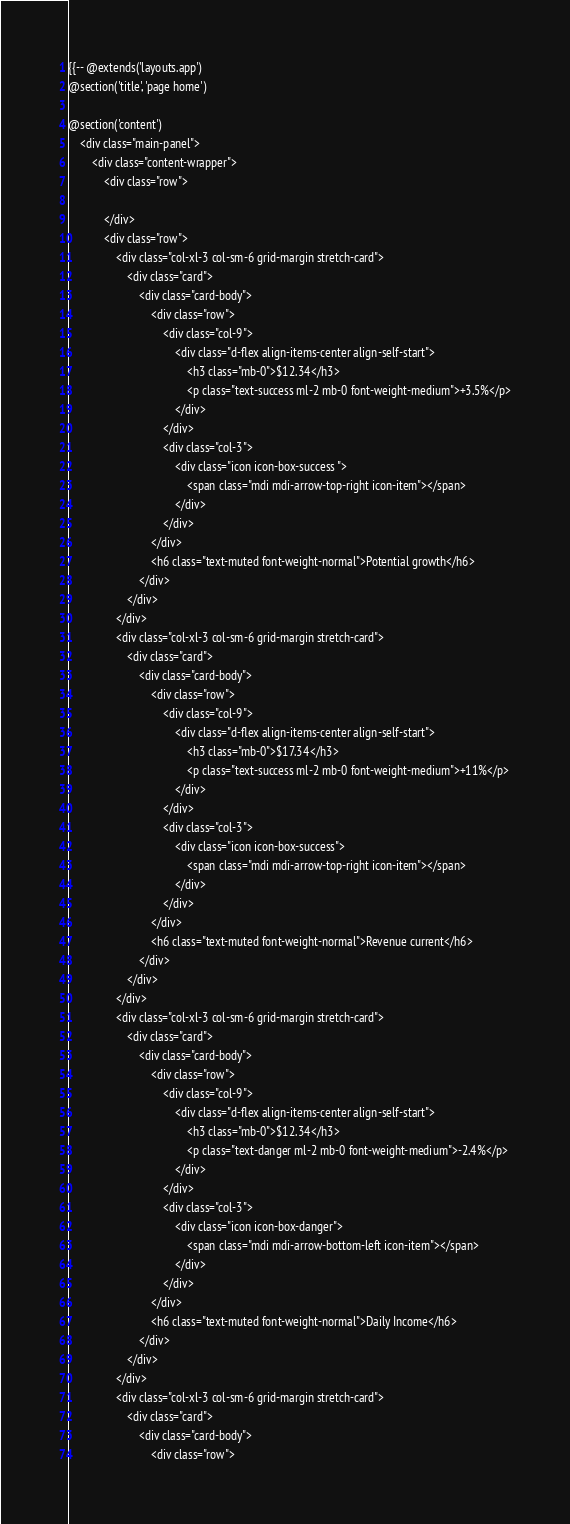Convert code to text. <code><loc_0><loc_0><loc_500><loc_500><_PHP_>{{-- @extends('layouts.app')
@section('title', 'page home')

@section('content')
    <div class="main-panel">
        <div class="content-wrapper">
            <div class="row">

            </div>
            <div class="row">
                <div class="col-xl-3 col-sm-6 grid-margin stretch-card">
                    <div class="card">
                        <div class="card-body">
                            <div class="row">
                                <div class="col-9">
                                    <div class="d-flex align-items-center align-self-start">
                                        <h3 class="mb-0">$12.34</h3>
                                        <p class="text-success ml-2 mb-0 font-weight-medium">+3.5%</p>
                                    </div>
                                </div>
                                <div class="col-3">
                                    <div class="icon icon-box-success ">
                                        <span class="mdi mdi-arrow-top-right icon-item"></span>
                                    </div>
                                </div>
                            </div>
                            <h6 class="text-muted font-weight-normal">Potential growth</h6>
                        </div>
                    </div>
                </div>
                <div class="col-xl-3 col-sm-6 grid-margin stretch-card">
                    <div class="card">
                        <div class="card-body">
                            <div class="row">
                                <div class="col-9">
                                    <div class="d-flex align-items-center align-self-start">
                                        <h3 class="mb-0">$17.34</h3>
                                        <p class="text-success ml-2 mb-0 font-weight-medium">+11%</p>
                                    </div>
                                </div>
                                <div class="col-3">
                                    <div class="icon icon-box-success">
                                        <span class="mdi mdi-arrow-top-right icon-item"></span>
                                    </div>
                                </div>
                            </div>
                            <h6 class="text-muted font-weight-normal">Revenue current</h6>
                        </div>
                    </div>
                </div>
                <div class="col-xl-3 col-sm-6 grid-margin stretch-card">
                    <div class="card">
                        <div class="card-body">
                            <div class="row">
                                <div class="col-9">
                                    <div class="d-flex align-items-center align-self-start">
                                        <h3 class="mb-0">$12.34</h3>
                                        <p class="text-danger ml-2 mb-0 font-weight-medium">-2.4%</p>
                                    </div>
                                </div>
                                <div class="col-3">
                                    <div class="icon icon-box-danger">
                                        <span class="mdi mdi-arrow-bottom-left icon-item"></span>
                                    </div>
                                </div>
                            </div>
                            <h6 class="text-muted font-weight-normal">Daily Income</h6>
                        </div>
                    </div>
                </div>
                <div class="col-xl-3 col-sm-6 grid-margin stretch-card">
                    <div class="card">
                        <div class="card-body">
                            <div class="row"></code> 